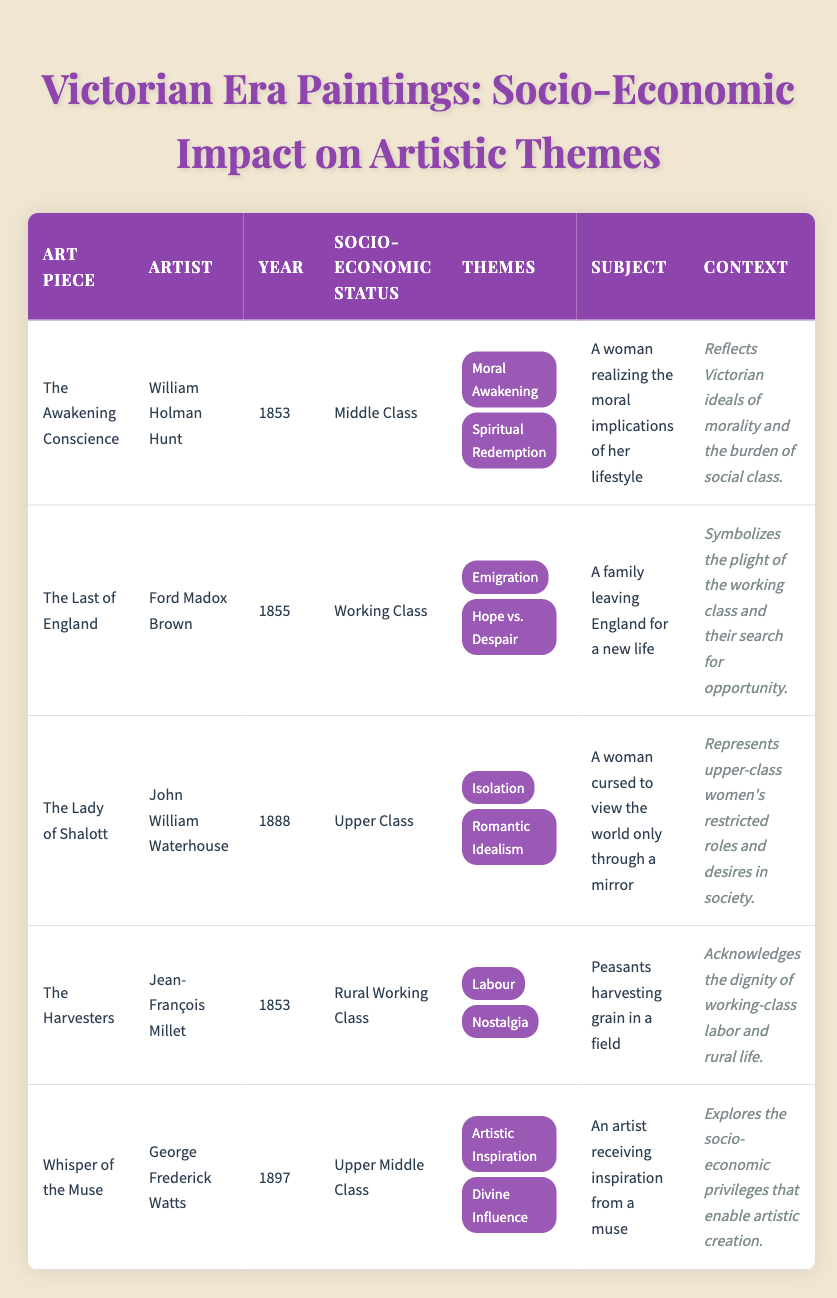What is the socio-economic status of "The Last of England"? The table directly lists the socio-economic status for each art piece. By locating "The Last of England" in the table, we see that its socio-economic status is "Working Class."
Answer: Working Class Which themes are represented in "The Awakening Conscience"? The table provides a list of themes for each art piece. For "The Awakening Conscience," the themes listed are "Moral Awakening" and "Spiritual Redemption."
Answer: Moral Awakening, Spiritual Redemption Are there any art pieces created by upper-class artists? To answer this question, we check the socio-economic status of each artist in the table. "The Lady of Shalott" and "Whisper of the Muse" both have an upper-class designation. Thus, there are art pieces from upper-class artists.
Answer: Yes How many art pieces focus on the theme of "Isolation"? We go through the table and identify which art pieces include "Isolation" in their themes. "The Lady of Shalott" is the only art piece that has this theme, so we count one occurrence.
Answer: 1 Which socio-economic status corresponds to the themes of "Emigration" and "Hope vs. Despair"? By identifying which art piece features these themes, we find them associated with "The Last of England," which has a socio-economic status of "Working Class."
Answer: Working Class What is the context of "Whisper of the Muse"? Looking at the table, we can find the context description for "Whisper of the Muse." It states that this artwork explores the socio-economic privileges that enable artistic creation.
Answer: Explores the socio-economic privileges that enable artistic creation How many different socio-economic statuses are represented in the table? By reviewing the art pieces, we count the distinct socio-economic statuses mentioned: Middle Class, Working Class, Upper Class, Rural Working Class, and Upper Middle Class, totaling five.
Answer: 5 Which artwork depicts a family leaving for a new life and what is its artist's socio-economic status? Referring to the table, we find that "The Last of England" depicts a family leaving for a new life. The socio-economic status of its artist, Ford Madox Brown, is "Working Class."
Answer: The Last of England, Working Class What is the most common theme among the art pieces listed? We analyze all the themes across every art piece in the table. The themes are varied; however, none is repeated across multiple art pieces, indicating there is no most common theme.
Answer: None 